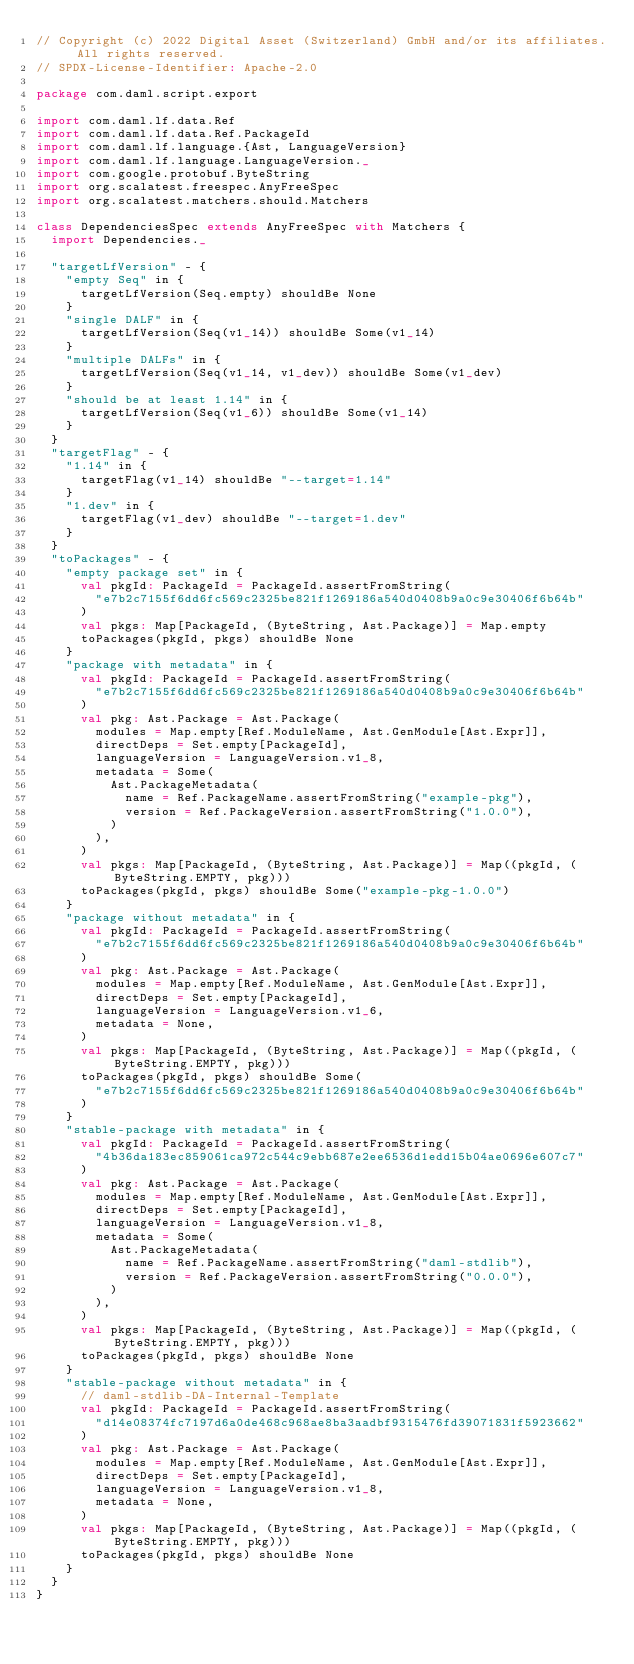<code> <loc_0><loc_0><loc_500><loc_500><_Scala_>// Copyright (c) 2022 Digital Asset (Switzerland) GmbH and/or its affiliates. All rights reserved.
// SPDX-License-Identifier: Apache-2.0

package com.daml.script.export

import com.daml.lf.data.Ref
import com.daml.lf.data.Ref.PackageId
import com.daml.lf.language.{Ast, LanguageVersion}
import com.daml.lf.language.LanguageVersion._
import com.google.protobuf.ByteString
import org.scalatest.freespec.AnyFreeSpec
import org.scalatest.matchers.should.Matchers

class DependenciesSpec extends AnyFreeSpec with Matchers {
  import Dependencies._

  "targetLfVersion" - {
    "empty Seq" in {
      targetLfVersion(Seq.empty) shouldBe None
    }
    "single DALF" in {
      targetLfVersion(Seq(v1_14)) shouldBe Some(v1_14)
    }
    "multiple DALFs" in {
      targetLfVersion(Seq(v1_14, v1_dev)) shouldBe Some(v1_dev)
    }
    "should be at least 1.14" in {
      targetLfVersion(Seq(v1_6)) shouldBe Some(v1_14)
    }
  }
  "targetFlag" - {
    "1.14" in {
      targetFlag(v1_14) shouldBe "--target=1.14"
    }
    "1.dev" in {
      targetFlag(v1_dev) shouldBe "--target=1.dev"
    }
  }
  "toPackages" - {
    "empty package set" in {
      val pkgId: PackageId = PackageId.assertFromString(
        "e7b2c7155f6dd6fc569c2325be821f1269186a540d0408b9a0c9e30406f6b64b"
      )
      val pkgs: Map[PackageId, (ByteString, Ast.Package)] = Map.empty
      toPackages(pkgId, pkgs) shouldBe None
    }
    "package with metadata" in {
      val pkgId: PackageId = PackageId.assertFromString(
        "e7b2c7155f6dd6fc569c2325be821f1269186a540d0408b9a0c9e30406f6b64b"
      )
      val pkg: Ast.Package = Ast.Package(
        modules = Map.empty[Ref.ModuleName, Ast.GenModule[Ast.Expr]],
        directDeps = Set.empty[PackageId],
        languageVersion = LanguageVersion.v1_8,
        metadata = Some(
          Ast.PackageMetadata(
            name = Ref.PackageName.assertFromString("example-pkg"),
            version = Ref.PackageVersion.assertFromString("1.0.0"),
          )
        ),
      )
      val pkgs: Map[PackageId, (ByteString, Ast.Package)] = Map((pkgId, (ByteString.EMPTY, pkg)))
      toPackages(pkgId, pkgs) shouldBe Some("example-pkg-1.0.0")
    }
    "package without metadata" in {
      val pkgId: PackageId = PackageId.assertFromString(
        "e7b2c7155f6dd6fc569c2325be821f1269186a540d0408b9a0c9e30406f6b64b"
      )
      val pkg: Ast.Package = Ast.Package(
        modules = Map.empty[Ref.ModuleName, Ast.GenModule[Ast.Expr]],
        directDeps = Set.empty[PackageId],
        languageVersion = LanguageVersion.v1_6,
        metadata = None,
      )
      val pkgs: Map[PackageId, (ByteString, Ast.Package)] = Map((pkgId, (ByteString.EMPTY, pkg)))
      toPackages(pkgId, pkgs) shouldBe Some(
        "e7b2c7155f6dd6fc569c2325be821f1269186a540d0408b9a0c9e30406f6b64b"
      )
    }
    "stable-package with metadata" in {
      val pkgId: PackageId = PackageId.assertFromString(
        "4b36da183ec859061ca972c544c9ebb687e2ee6536d1edd15b04ae0696e607c7"
      )
      val pkg: Ast.Package = Ast.Package(
        modules = Map.empty[Ref.ModuleName, Ast.GenModule[Ast.Expr]],
        directDeps = Set.empty[PackageId],
        languageVersion = LanguageVersion.v1_8,
        metadata = Some(
          Ast.PackageMetadata(
            name = Ref.PackageName.assertFromString("daml-stdlib"),
            version = Ref.PackageVersion.assertFromString("0.0.0"),
          )
        ),
      )
      val pkgs: Map[PackageId, (ByteString, Ast.Package)] = Map((pkgId, (ByteString.EMPTY, pkg)))
      toPackages(pkgId, pkgs) shouldBe None
    }
    "stable-package without metadata" in {
      // daml-stdlib-DA-Internal-Template
      val pkgId: PackageId = PackageId.assertFromString(
        "d14e08374fc7197d6a0de468c968ae8ba3aadbf9315476fd39071831f5923662"
      )
      val pkg: Ast.Package = Ast.Package(
        modules = Map.empty[Ref.ModuleName, Ast.GenModule[Ast.Expr]],
        directDeps = Set.empty[PackageId],
        languageVersion = LanguageVersion.v1_8,
        metadata = None,
      )
      val pkgs: Map[PackageId, (ByteString, Ast.Package)] = Map((pkgId, (ByteString.EMPTY, pkg)))
      toPackages(pkgId, pkgs) shouldBe None
    }
  }
}
</code> 